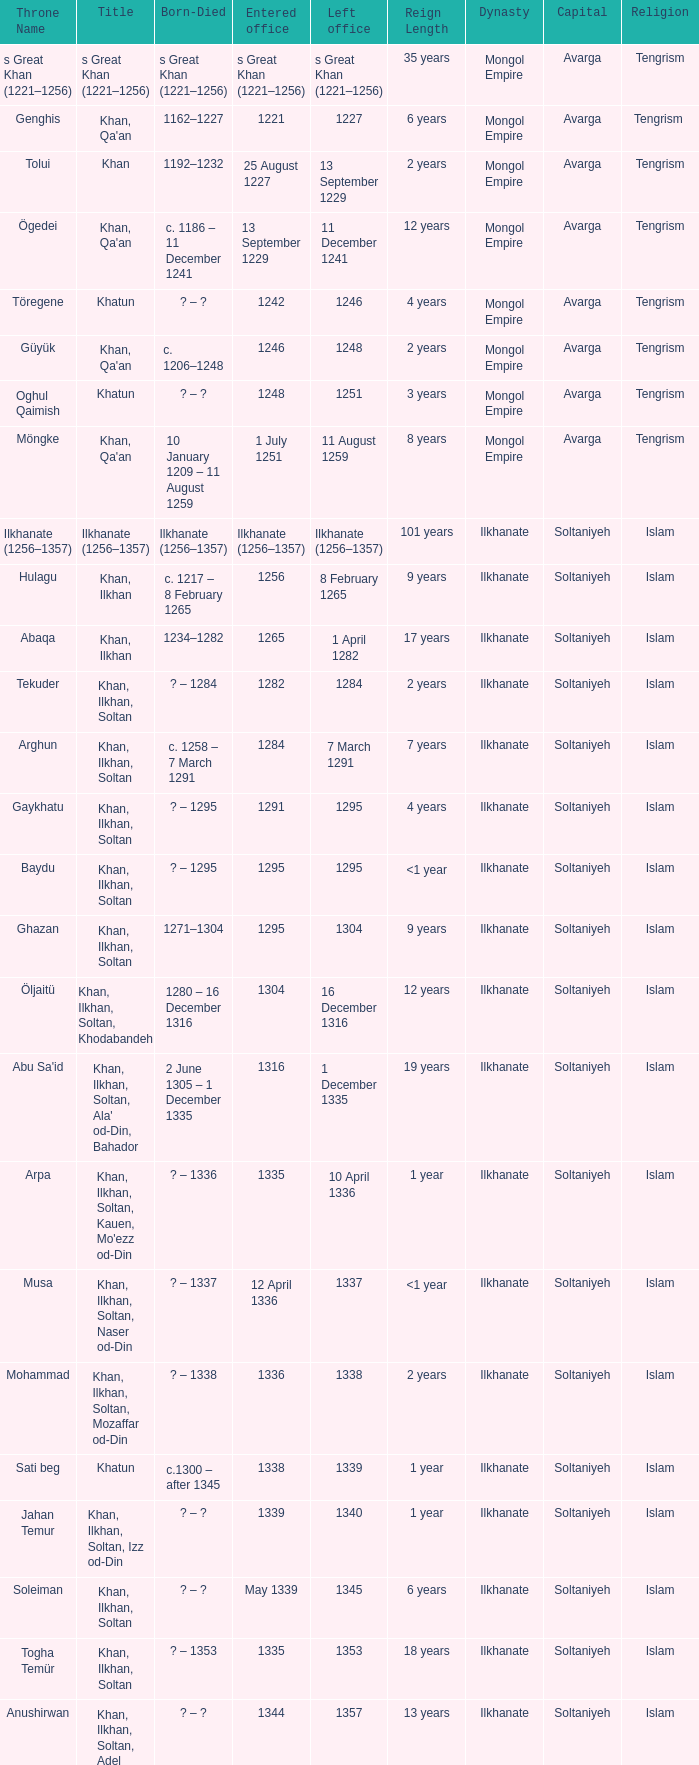What is the entered office that has 1337 as the left office? 12 April 1336. 